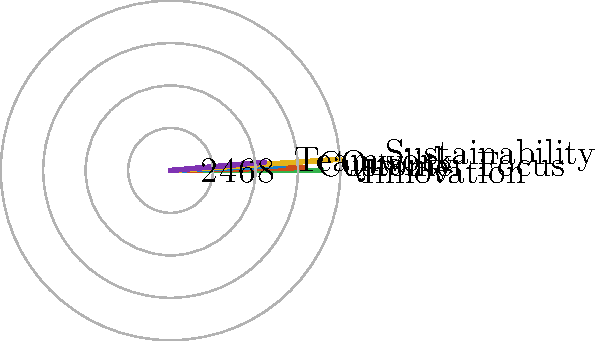As a copywriter, you've been tasked with creating a narrative to accompany a radial chart visualizing a company's brand values. The chart shows five key values: Innovation, Quality, Customer Focus, Sustainability, and Teamwork. Given that the company wants to emphasize its strongest areas, which two brand values should be the focus of your narrative based on the chart? To determine which two brand values should be the focus of the narrative, we need to analyze the radial chart and identify the values with the highest scores. Let's break down the process:

1. Examine the chart:
   The radial chart displays five brand values, each represented by a colored line extending from the center.

2. Interpret the scale:
   The concentric circles represent score levels, with the outermost circle labeled as 8.

3. Evaluate each value's score:
   - Innovation: Extends to the 8 mark
   - Quality: Reaches between 6 and 8, approximately 7
   - Customer Focus: Extends to 6
   - Sustainability: Reaches beyond 8, approximately 9
   - Teamwork: Extends to 5

4. Identify the highest scores:
   The two values with the highest scores are:
   a) Sustainability (≈9)
   b) Innovation (8)

5. Conclusion:
   Based on the chart, the copywriter should focus the narrative on Sustainability and Innovation, as these are the company's strongest brand values according to the visualization.
Answer: Sustainability and Innovation 